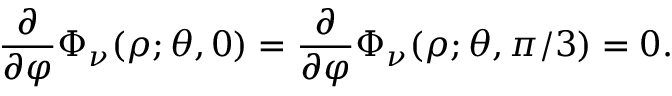Convert formula to latex. <formula><loc_0><loc_0><loc_500><loc_500>\frac { \partial } { \partial \varphi } \Phi _ { \nu } ( \rho ; \theta , 0 ) = \frac { \partial } { \partial \varphi } \Phi _ { \nu } ( \rho ; \theta , \pi / 3 ) = 0 .</formula> 